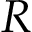Convert formula to latex. <formula><loc_0><loc_0><loc_500><loc_500>R</formula> 